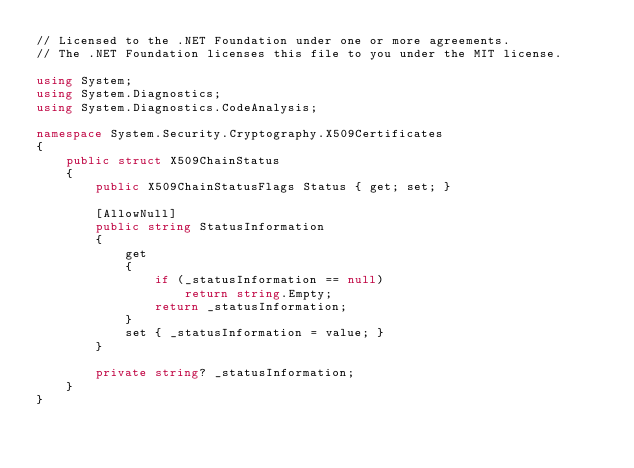<code> <loc_0><loc_0><loc_500><loc_500><_C#_>// Licensed to the .NET Foundation under one or more agreements.
// The .NET Foundation licenses this file to you under the MIT license.

using System;
using System.Diagnostics;
using System.Diagnostics.CodeAnalysis;

namespace System.Security.Cryptography.X509Certificates
{
    public struct X509ChainStatus
    {
        public X509ChainStatusFlags Status { get; set; }

        [AllowNull]
        public string StatusInformation
        {
            get
            {
                if (_statusInformation == null)
                    return string.Empty;
                return _statusInformation;
            }
            set { _statusInformation = value; }
        }

        private string? _statusInformation;
    }
}
</code> 